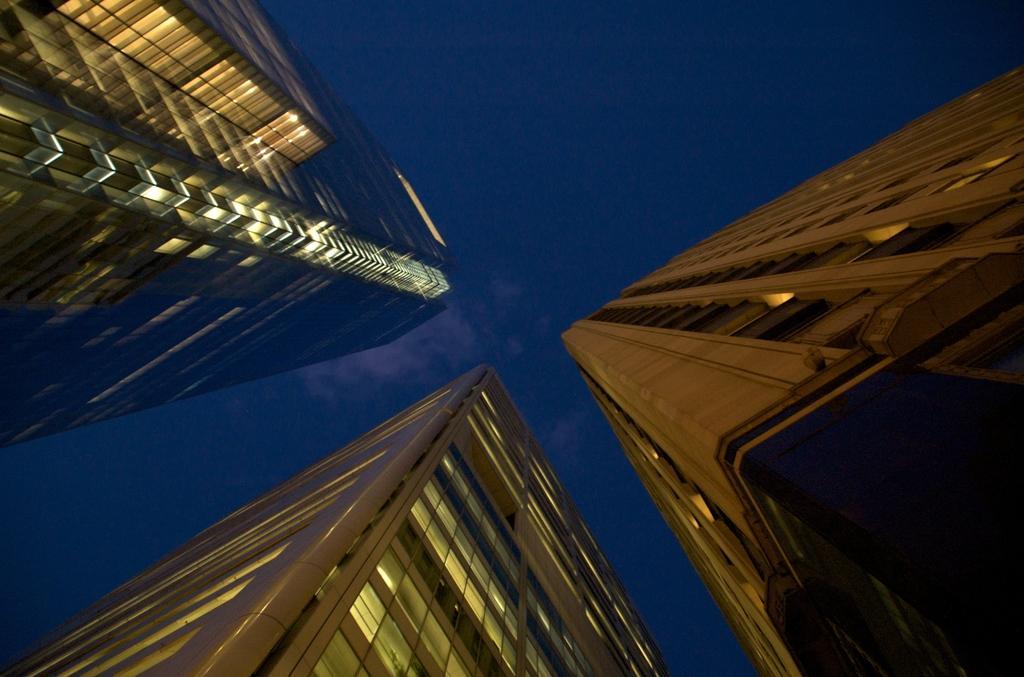How would you summarize this image in a sentence or two? In this image I can see the buildings with some lights. In the background I can see the blue sky. 